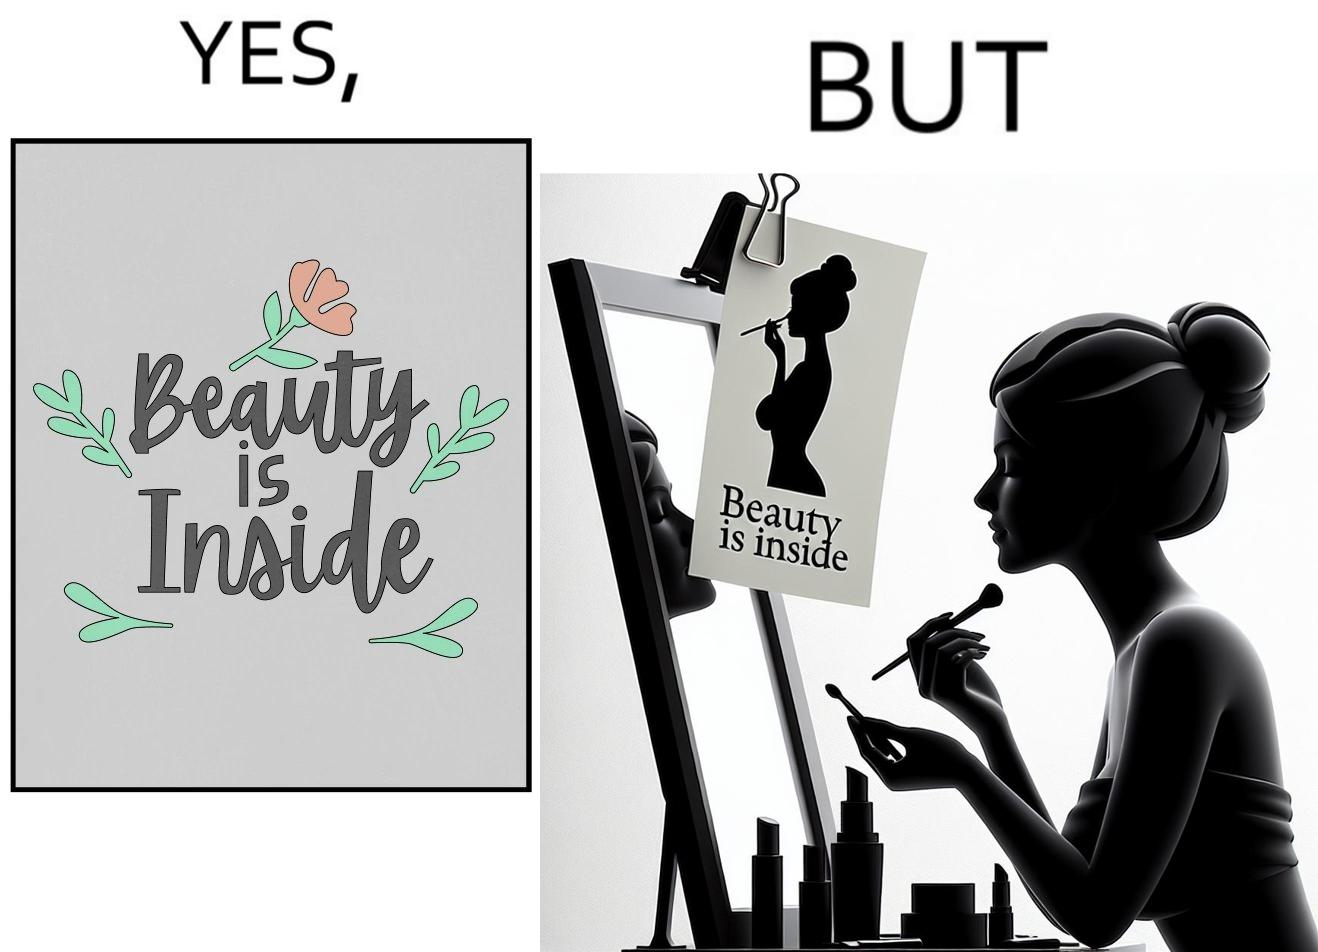What is shown in this image? The image is satirical because while the text on the paper says that beauty lies inside, the woman ignores the note and continues to apply makeup to improve her outer beauty. 